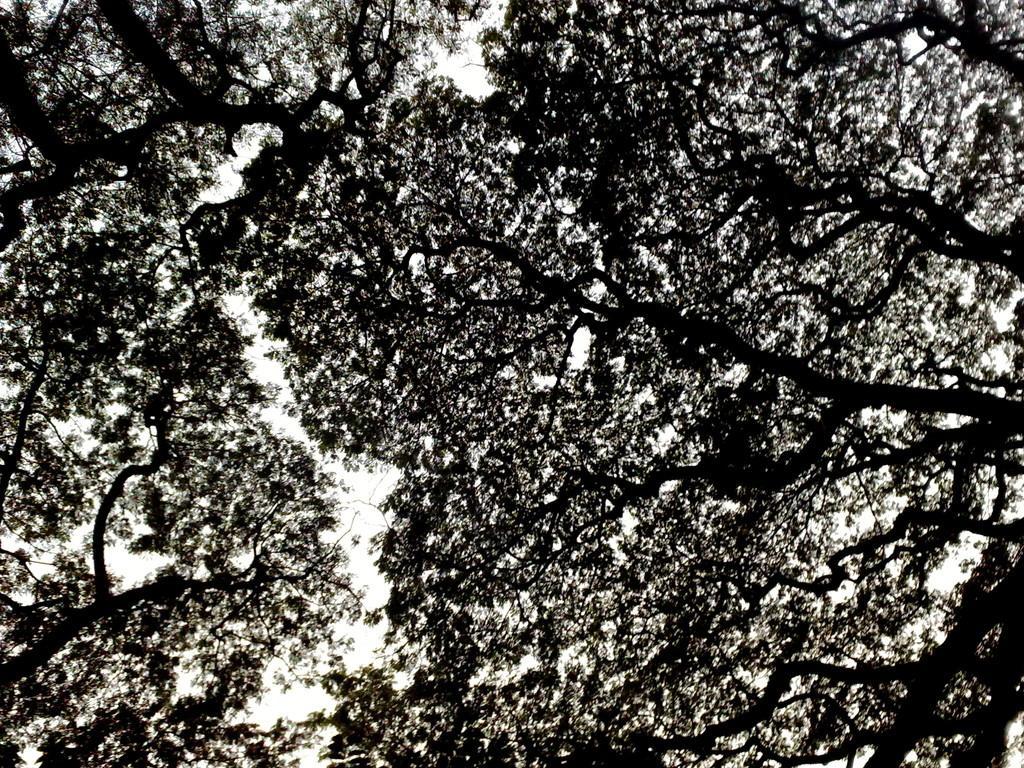In one or two sentences, can you explain what this image depicts? In this image, we can see some trees and the sky. 